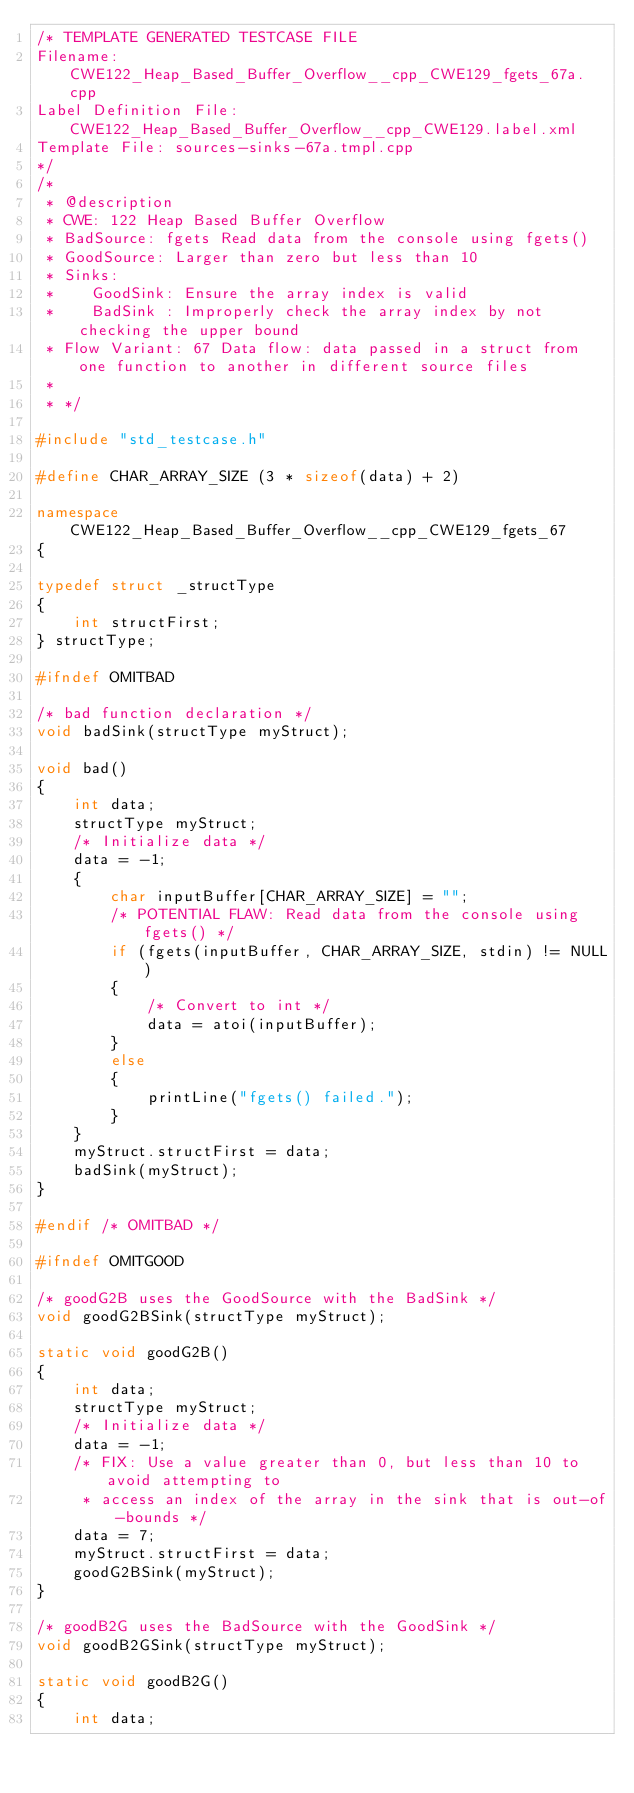Convert code to text. <code><loc_0><loc_0><loc_500><loc_500><_C++_>/* TEMPLATE GENERATED TESTCASE FILE
Filename: CWE122_Heap_Based_Buffer_Overflow__cpp_CWE129_fgets_67a.cpp
Label Definition File: CWE122_Heap_Based_Buffer_Overflow__cpp_CWE129.label.xml
Template File: sources-sinks-67a.tmpl.cpp
*/
/*
 * @description
 * CWE: 122 Heap Based Buffer Overflow
 * BadSource: fgets Read data from the console using fgets()
 * GoodSource: Larger than zero but less than 10
 * Sinks:
 *    GoodSink: Ensure the array index is valid
 *    BadSink : Improperly check the array index by not checking the upper bound
 * Flow Variant: 67 Data flow: data passed in a struct from one function to another in different source files
 *
 * */

#include "std_testcase.h"

#define CHAR_ARRAY_SIZE (3 * sizeof(data) + 2)

namespace CWE122_Heap_Based_Buffer_Overflow__cpp_CWE129_fgets_67
{

typedef struct _structType
{
    int structFirst;
} structType;

#ifndef OMITBAD

/* bad function declaration */
void badSink(structType myStruct);

void bad()
{
    int data;
    structType myStruct;
    /* Initialize data */
    data = -1;
    {
        char inputBuffer[CHAR_ARRAY_SIZE] = "";
        /* POTENTIAL FLAW: Read data from the console using fgets() */
        if (fgets(inputBuffer, CHAR_ARRAY_SIZE, stdin) != NULL)
        {
            /* Convert to int */
            data = atoi(inputBuffer);
        }
        else
        {
            printLine("fgets() failed.");
        }
    }
    myStruct.structFirst = data;
    badSink(myStruct);
}

#endif /* OMITBAD */

#ifndef OMITGOOD

/* goodG2B uses the GoodSource with the BadSink */
void goodG2BSink(structType myStruct);

static void goodG2B()
{
    int data;
    structType myStruct;
    /* Initialize data */
    data = -1;
    /* FIX: Use a value greater than 0, but less than 10 to avoid attempting to
     * access an index of the array in the sink that is out-of-bounds */
    data = 7;
    myStruct.structFirst = data;
    goodG2BSink(myStruct);
}

/* goodB2G uses the BadSource with the GoodSink */
void goodB2GSink(structType myStruct);

static void goodB2G()
{
    int data;</code> 